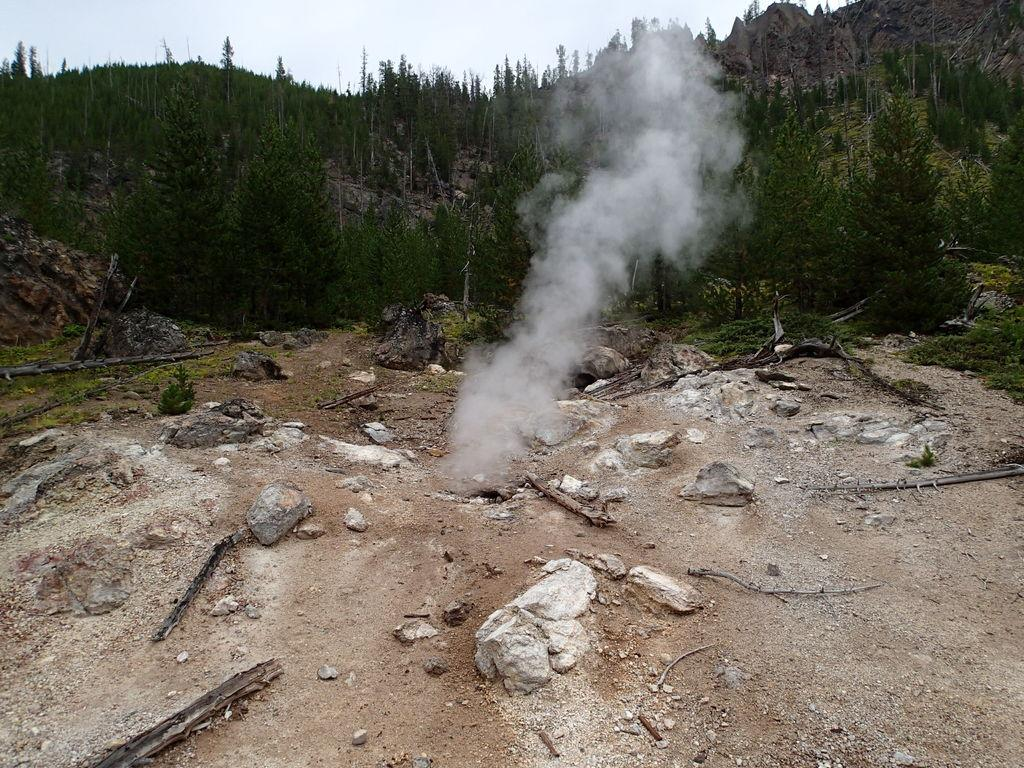What type of terrain is visible in the image? There is a land in the image. What can be found on the land? There are rocks on the land. What else is present in the image besides the land and rocks? There is smoke in the image. What can be seen in the background of the image? There are trees, a mountain, and the sky visible in the background of the image. Can you tell me how many zebras are standing on the branch in the image? There are no zebras or branches present in the image. 